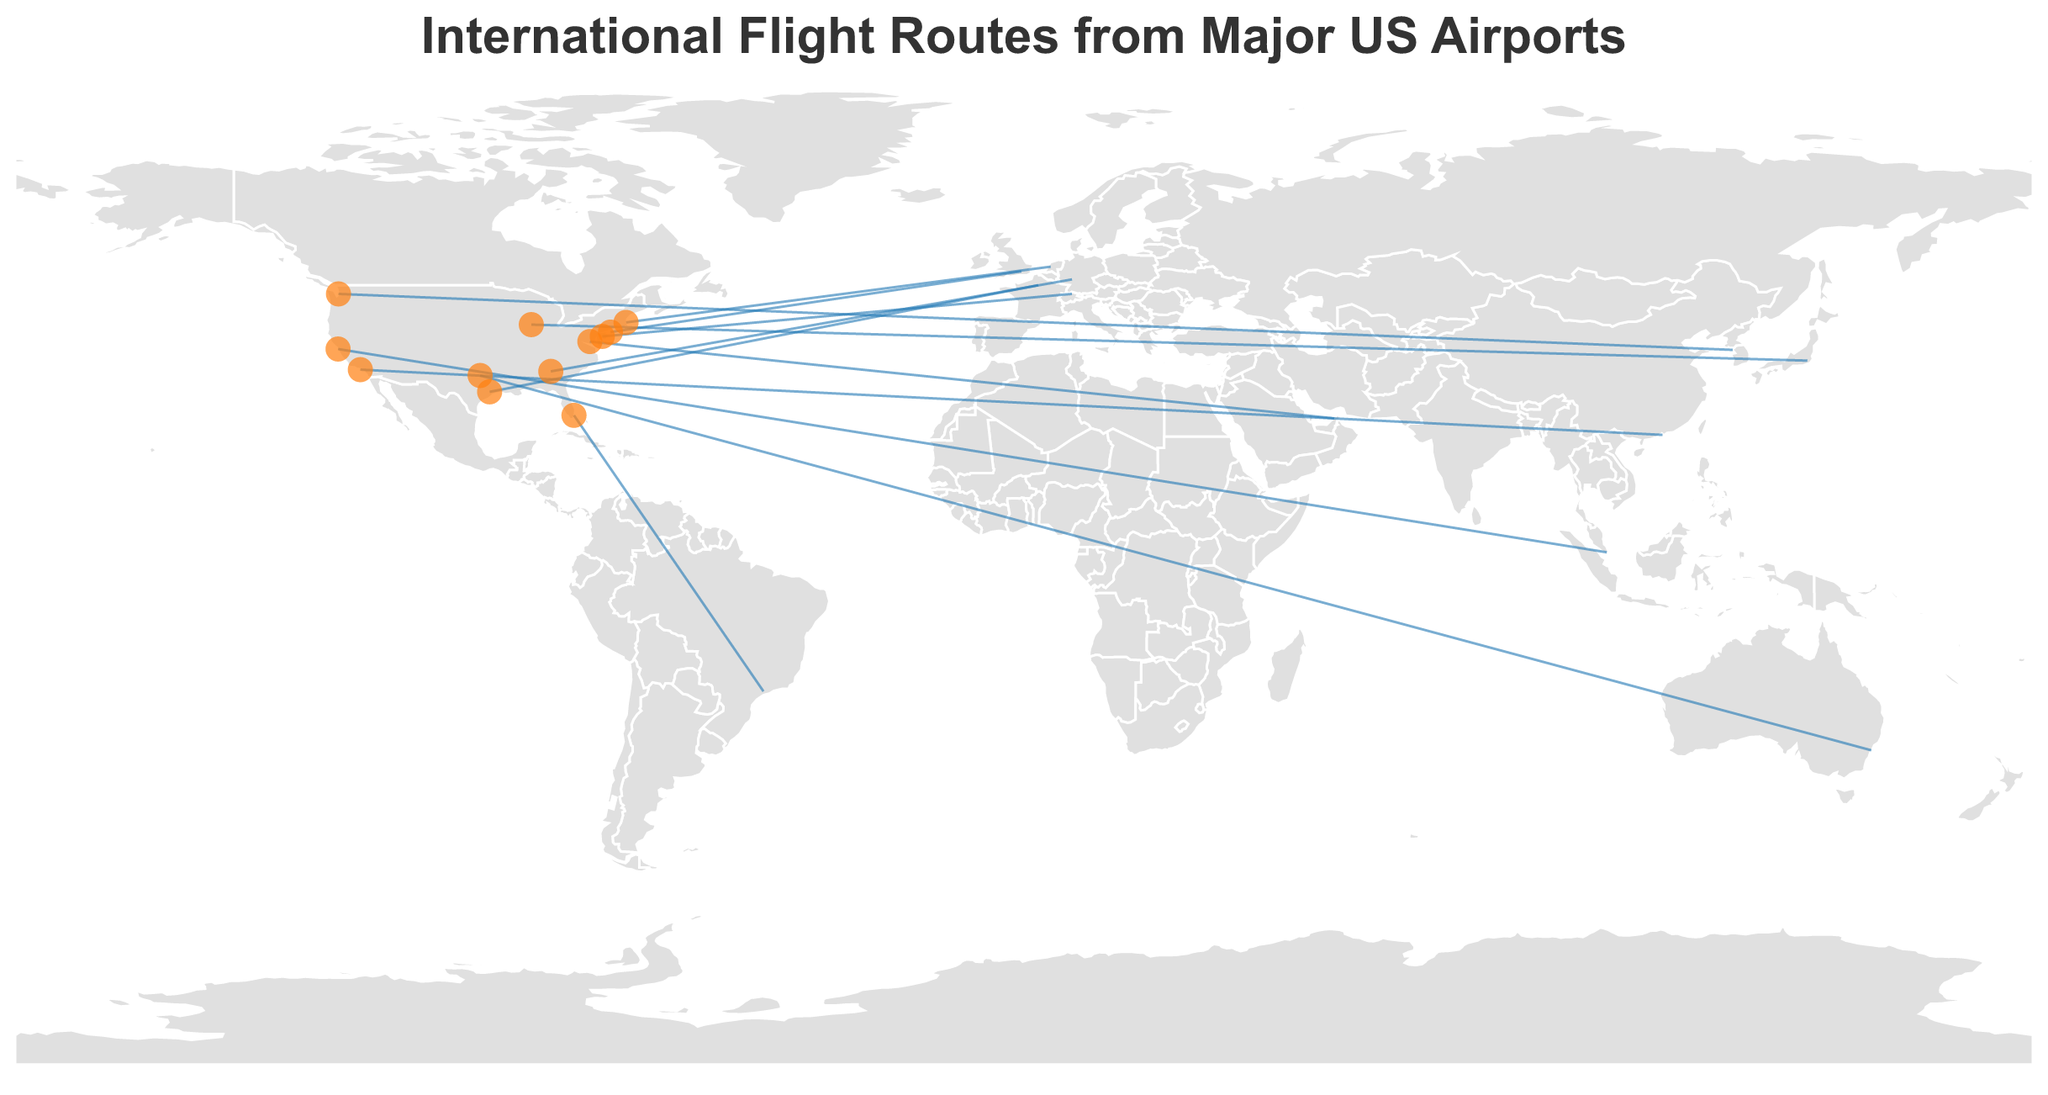What is the most frequent international flight route from a major US airport to a business destination? The flight route with the highest number of flights per week can be identified. According to the data, New York (JFK) to London (LHR) has 70 flights per week, which is the highest.
Answer: New York (JFK) to London (LHR) How many flights per week travel from Atlanta (ATL) to Frankfurt (FRA)? The number of flights per week from Atlanta (ATL) to Frankfurt (FRA) can be directly read from the data. There are 42 flights per week on this route.
Answer: 42 Which destination has the highest number of business class seats per week? To determine the destination with the highest number of business class seats, we need to look at the "Business_class_seats" field. London (LHR) has 2800 business class seats per week, which is the highest.
Answer: London (LHR) Compare the number of flights per week from Los Angeles (LAX) to Hong Kong (HKG) and from Chicago (ORD) to Tokyo (HND). Which one has more flights? Los Angeles (LAX) to Hong Kong (HKG) has 35 flights per week, while Chicago (ORD) to Tokyo (HND) has 28 flights per week. Therefore, Los Angeles (LAX) to Hong Kong (HKG) has more flights.
Answer: Los Angeles (LAX) to Hong Kong (HKG) What is the combined total of business class seats for flights from Miami (MIA) to São Paulo (GRU) and from Houston (IAH) to Paris (CDG)? Miami (MIA) to São Paulo (GRU) has 1120 business class seats, and Houston (IAH) to Paris (CDG) has 1120 business class seats. Combined total is 1120 + 1120 = 2240.
Answer: 2240 How many routes have more than 30 flights per week? By examining the data, routes with more than 30 flights per week are the flights from New York (JFK) to London (LHR) and Los Angeles (LAX) to Hong Kong (HKG). There are a total of two such routes.
Answer: 2 Identify the route with the fewest flights per week. By looking at the "Flights_per_week" values, the route with the fewest flights per week is from Washington D.C. (IAD) to Dubai (DXB) and from Philadelphia (PHL) to Zurich (ZRH), both with 14 flights per week.
Answer: Washington D.C. (IAD) to Dubai (DXB) and Philadelphia (PHL) to Zurich (ZRH) Which US airport has the most international flight routes based on the provided data? Counting the occurrences of each originating airport, New York (JFK) has the most routes with three destinations: London (LHR), Tokyo (HND).
Answer: New York (JFK) How does the number of flights per week from San Francisco (SFO) to Singapore (SIN) compare to the number of flights from Dallas (DFW) to Sydney (SYD)? San Francisco (SFO) to Singapore (SIN) has 21 flights per week, whereas Dallas (DFW) to Sydney (SYD) has 14 flights per week. San Francisco (SFO) to Singapore (SIN) has more flights.
Answer: San Francisco (SFO) to Singapore (SIN) What is the average number of business class seats per flight for the route from Boston (BOS) to Amsterdam (AMS)? The total number of business class seats for this route is 840, and there are 21 flights per week. The average is calculated as 840 / 21 = 40 seats per flight.
Answer: 40 